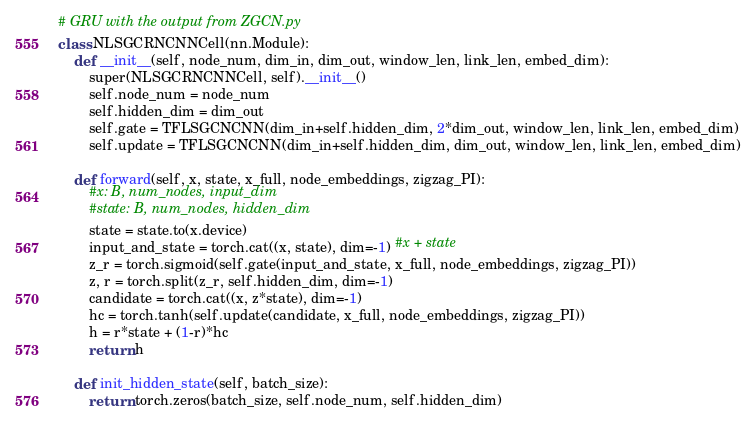Convert code to text. <code><loc_0><loc_0><loc_500><loc_500><_Python_>
# GRU with the output from ZGCN.py
class NLSGCRNCNNCell(nn.Module):
    def __init__(self, node_num, dim_in, dim_out, window_len, link_len, embed_dim):
        super(NLSGCRNCNNCell, self).__init__()
        self.node_num = node_num
        self.hidden_dim = dim_out
        self.gate = TFLSGCNCNN(dim_in+self.hidden_dim, 2*dim_out, window_len, link_len, embed_dim)
        self.update = TFLSGCNCNN(dim_in+self.hidden_dim, dim_out, window_len, link_len, embed_dim)

    def forward(self, x, state, x_full, node_embeddings, zigzag_PI):
        #x: B, num_nodes, input_dim
        #state: B, num_nodes, hidden_dim
        state = state.to(x.device)
        input_and_state = torch.cat((x, state), dim=-1) #x + state
        z_r = torch.sigmoid(self.gate(input_and_state, x_full, node_embeddings, zigzag_PI))
        z, r = torch.split(z_r, self.hidden_dim, dim=-1)
        candidate = torch.cat((x, z*state), dim=-1)
        hc = torch.tanh(self.update(candidate, x_full, node_embeddings, zigzag_PI))
        h = r*state + (1-r)*hc
        return h

    def init_hidden_state(self, batch_size):
        return torch.zeros(batch_size, self.node_num, self.hidden_dim)
</code> 